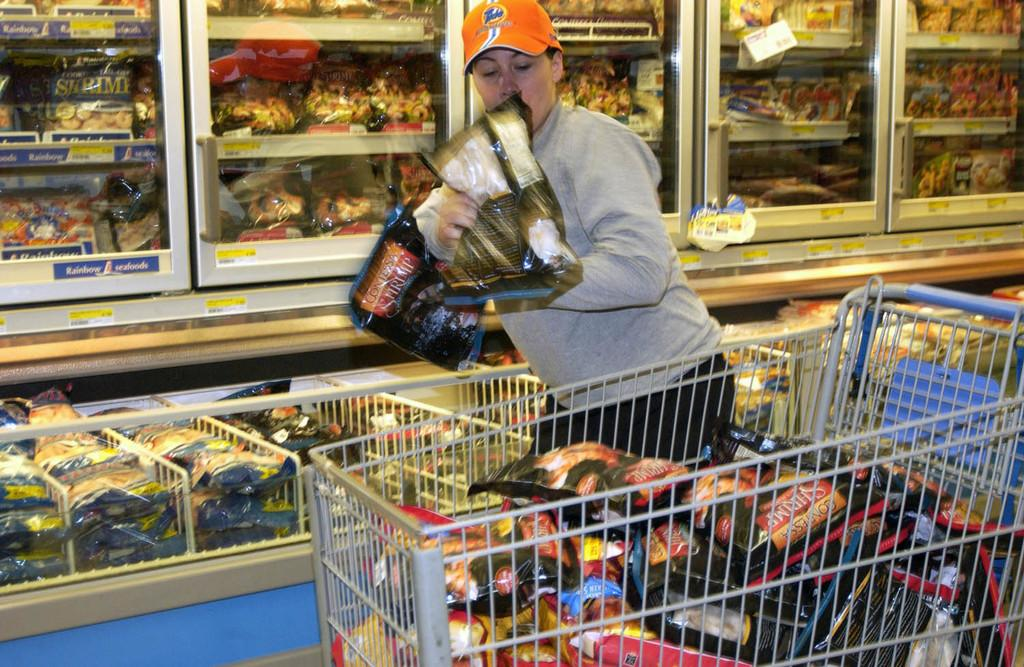<image>
Write a terse but informative summary of the picture. A woman is shopping and putting Contessa Shrimp bags into her cart. 